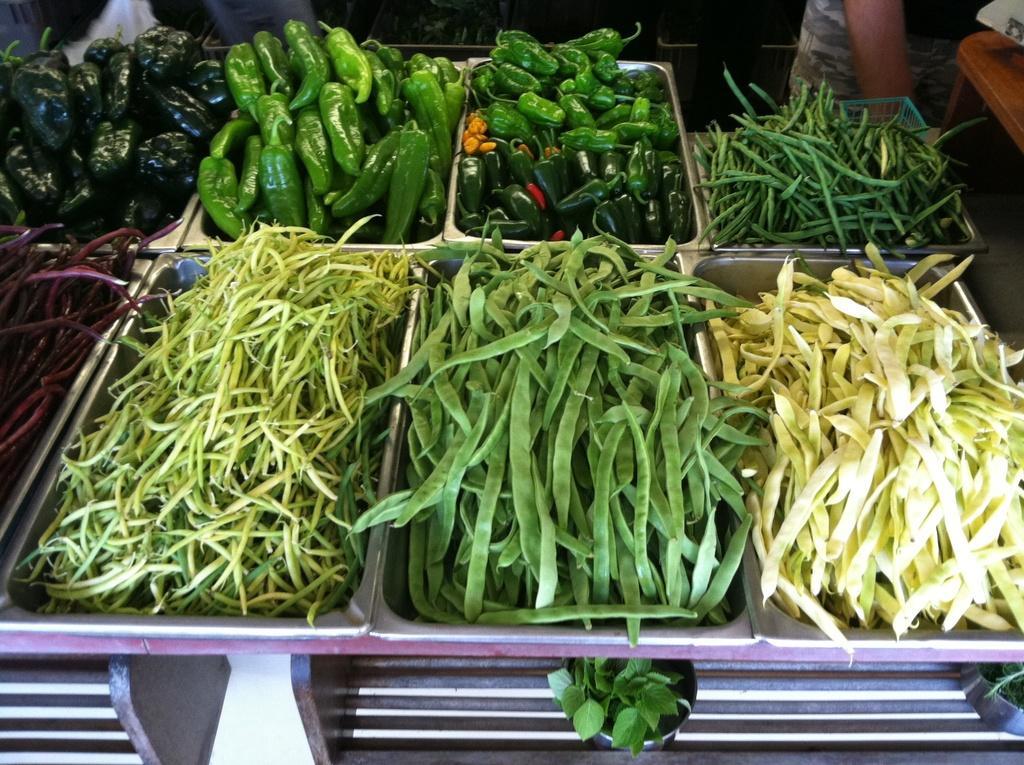Please provide a concise description of this image. This image consists of raw vegetables which are in the center. On the right side there is a bench, and at the top the legs of the persons are visible. 